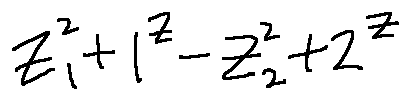Convert formula to latex. <formula><loc_0><loc_0><loc_500><loc_500>z _ { 1 } ^ { 2 } + 1 ^ { z } - z _ { 2 } ^ { 2 } + 2 ^ { z }</formula> 